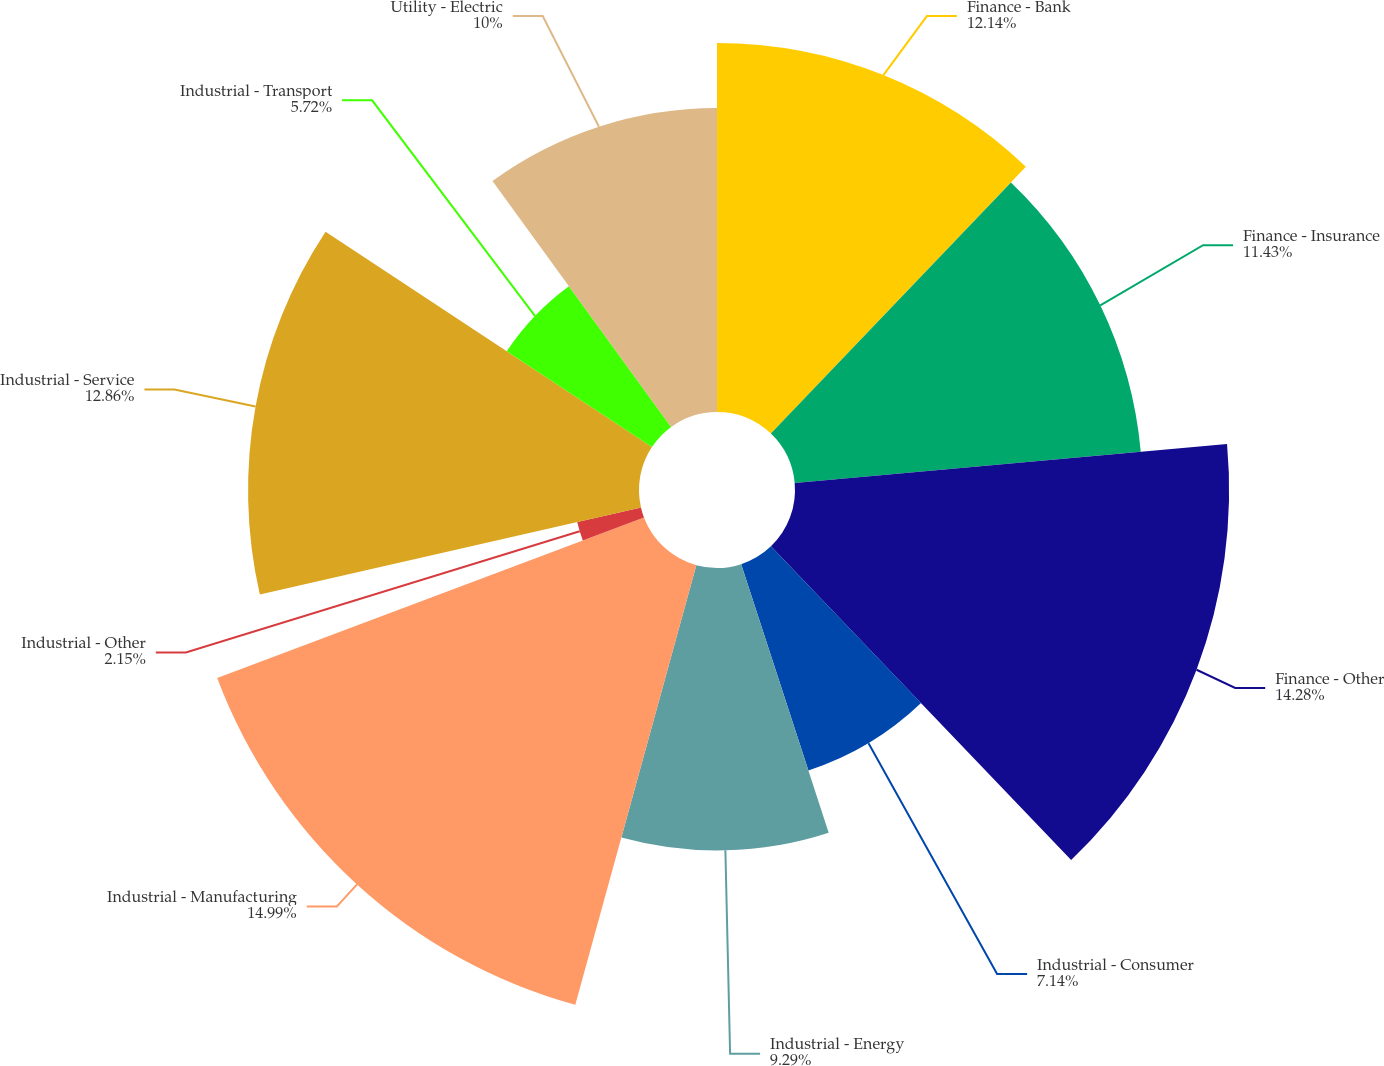Convert chart. <chart><loc_0><loc_0><loc_500><loc_500><pie_chart><fcel>Finance - Bank<fcel>Finance - Insurance<fcel>Finance - Other<fcel>Industrial - Consumer<fcel>Industrial - Energy<fcel>Industrial - Manufacturing<fcel>Industrial - Other<fcel>Industrial - Service<fcel>Industrial - Transport<fcel>Utility - Electric<nl><fcel>12.14%<fcel>11.43%<fcel>14.28%<fcel>7.14%<fcel>9.29%<fcel>15.0%<fcel>2.15%<fcel>12.86%<fcel>5.72%<fcel>10.0%<nl></chart> 